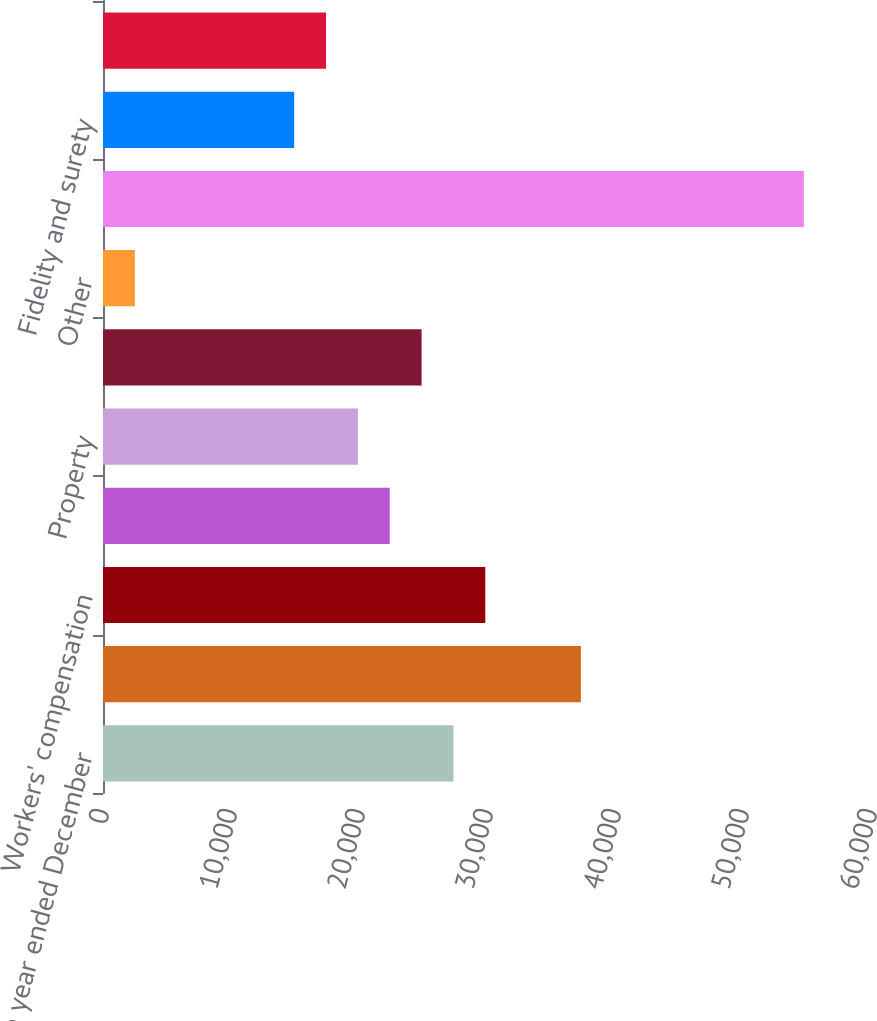Convert chart. <chart><loc_0><loc_0><loc_500><loc_500><bar_chart><fcel>(for the year ended December<fcel>Commercial multi-peril<fcel>Workers' compensation<fcel>Commercial automobile<fcel>Property<fcel>General liability<fcel>Other<fcel>Total Business Insurance<fcel>Fidelity and surety<fcel>International<nl><fcel>27378.8<fcel>37334<fcel>29867.6<fcel>22401.2<fcel>19912.4<fcel>24890<fcel>2490.8<fcel>54755.6<fcel>14934.8<fcel>17423.6<nl></chart> 